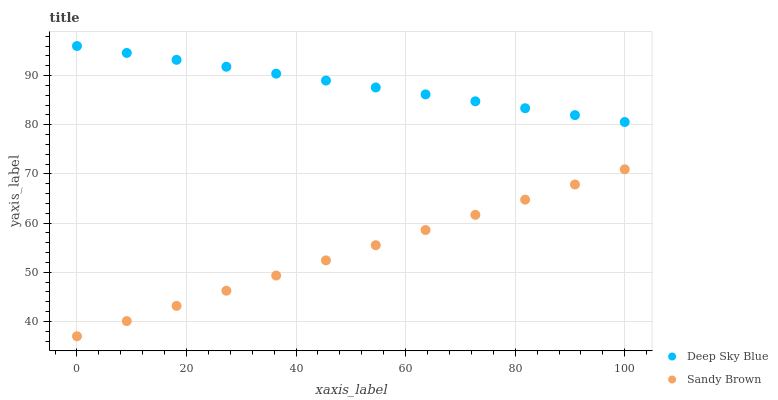Does Sandy Brown have the minimum area under the curve?
Answer yes or no. Yes. Does Deep Sky Blue have the maximum area under the curve?
Answer yes or no. Yes. Does Deep Sky Blue have the minimum area under the curve?
Answer yes or no. No. Is Deep Sky Blue the smoothest?
Answer yes or no. Yes. Is Sandy Brown the roughest?
Answer yes or no. Yes. Is Deep Sky Blue the roughest?
Answer yes or no. No. Does Sandy Brown have the lowest value?
Answer yes or no. Yes. Does Deep Sky Blue have the lowest value?
Answer yes or no. No. Does Deep Sky Blue have the highest value?
Answer yes or no. Yes. Is Sandy Brown less than Deep Sky Blue?
Answer yes or no. Yes. Is Deep Sky Blue greater than Sandy Brown?
Answer yes or no. Yes. Does Sandy Brown intersect Deep Sky Blue?
Answer yes or no. No. 